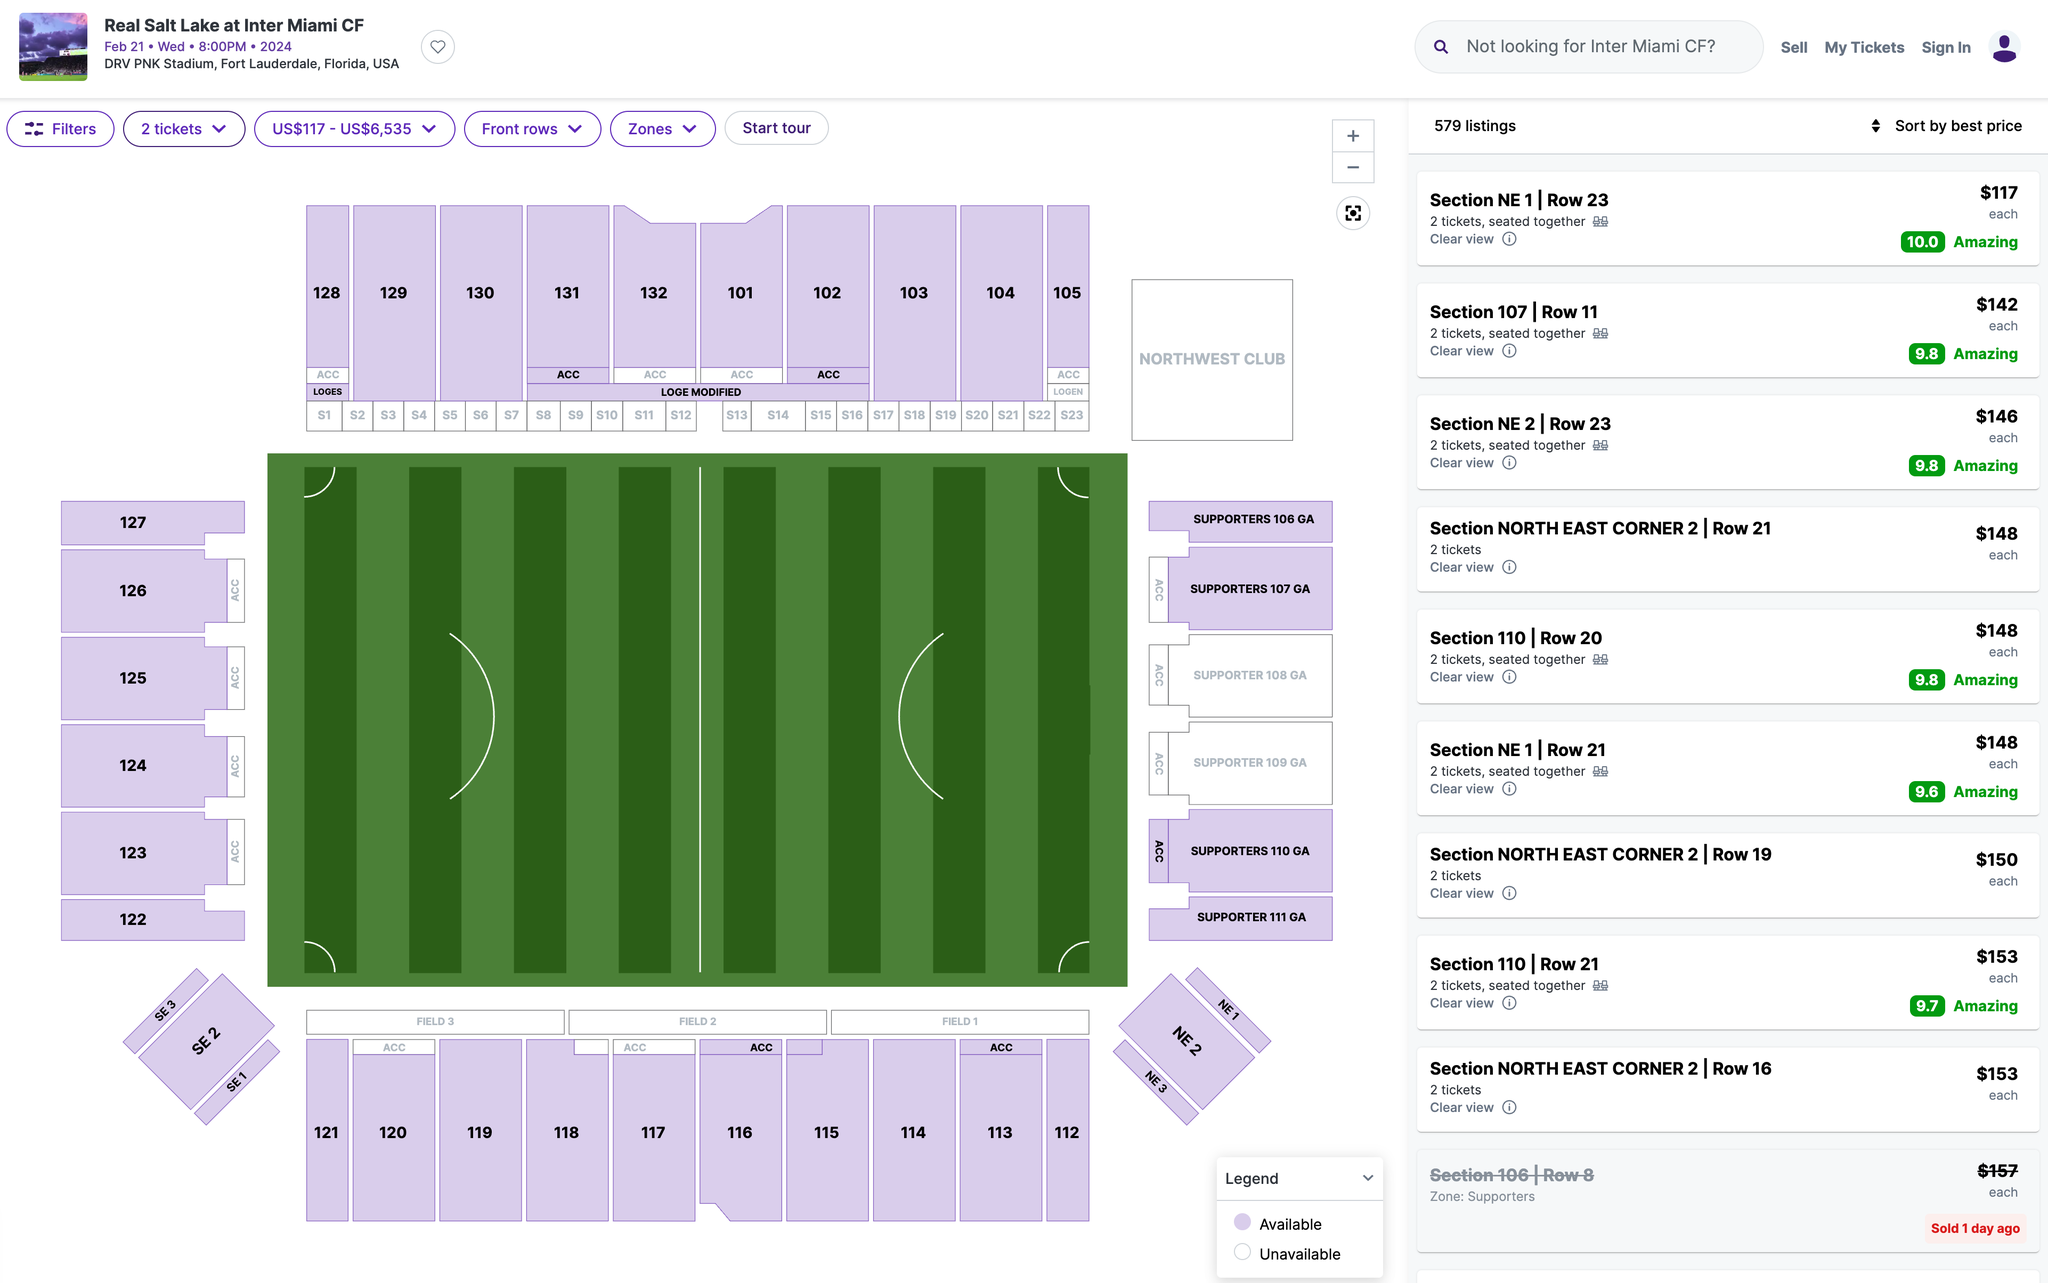Which section's ticket would you recommend I purchase? I recommend purchasing tickets in Section 107. This section is located on the west side of the stadium, and it offers a great view of the field. Additionally, this section is relatively close to the action, so you will be able to feel the excitement of the game. 